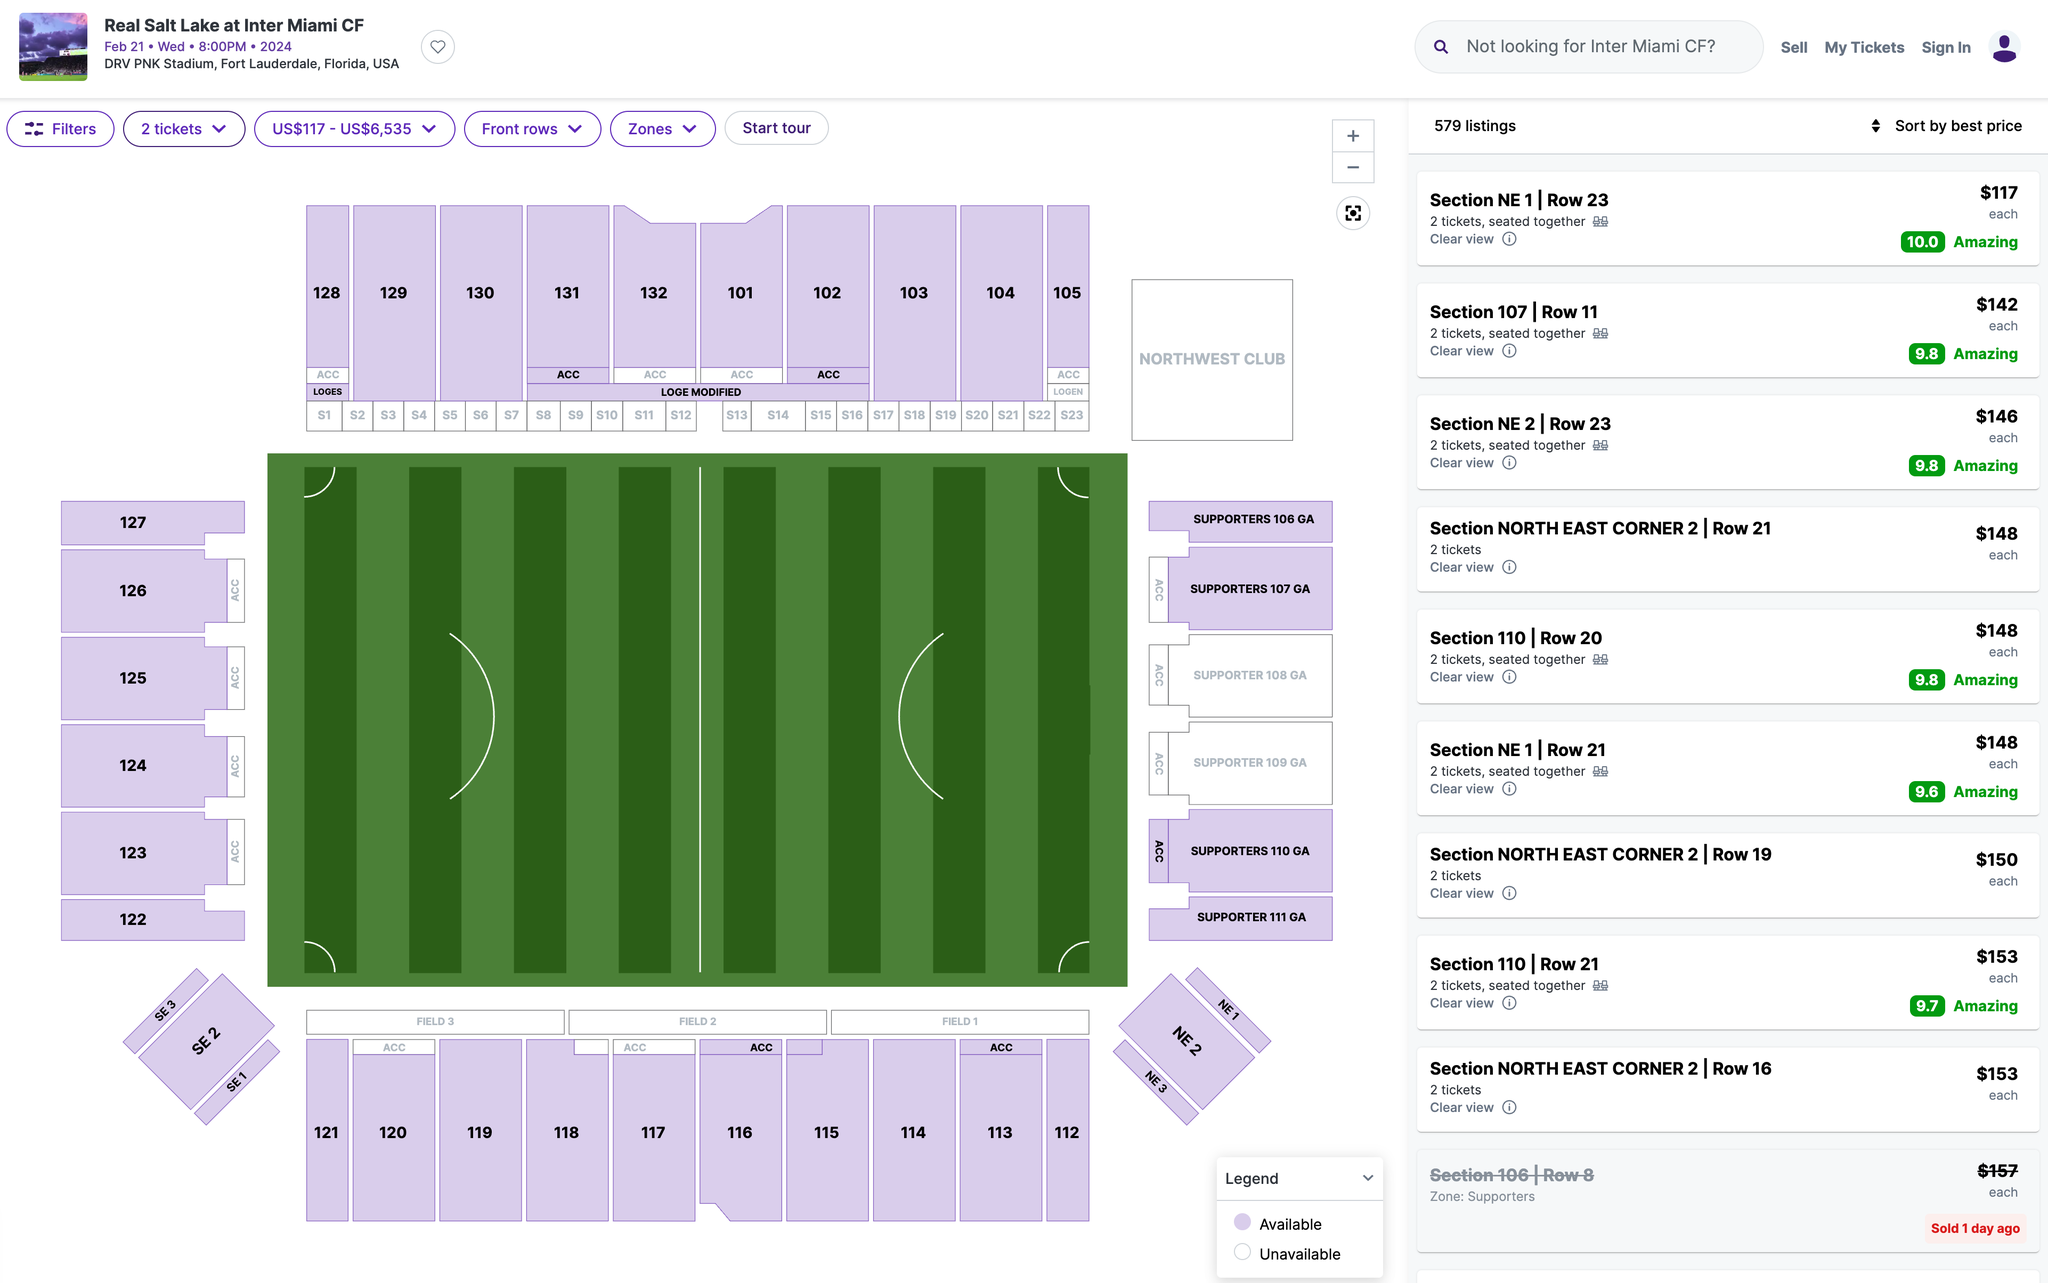Which section's ticket would you recommend I purchase? I recommend purchasing tickets in Section 107. This section is located on the west side of the stadium, and it offers a great view of the field. Additionally, this section is relatively close to the action, so you will be able to feel the excitement of the game. 